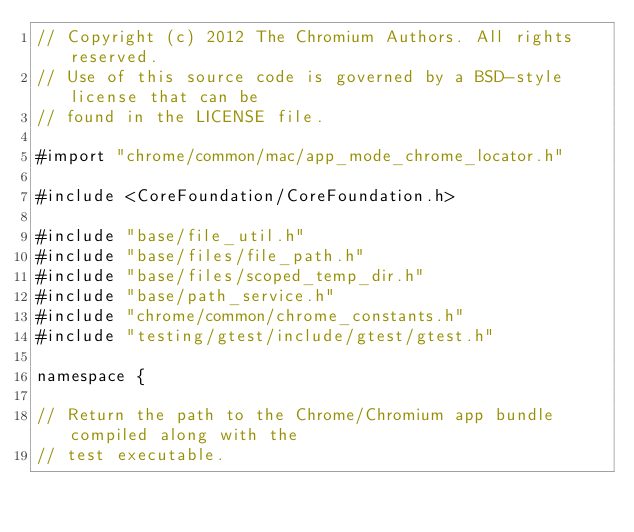<code> <loc_0><loc_0><loc_500><loc_500><_ObjectiveC_>// Copyright (c) 2012 The Chromium Authors. All rights reserved.
// Use of this source code is governed by a BSD-style license that can be
// found in the LICENSE file.

#import "chrome/common/mac/app_mode_chrome_locator.h"

#include <CoreFoundation/CoreFoundation.h>

#include "base/file_util.h"
#include "base/files/file_path.h"
#include "base/files/scoped_temp_dir.h"
#include "base/path_service.h"
#include "chrome/common/chrome_constants.h"
#include "testing/gtest/include/gtest/gtest.h"

namespace {

// Return the path to the Chrome/Chromium app bundle compiled along with the
// test executable.</code> 